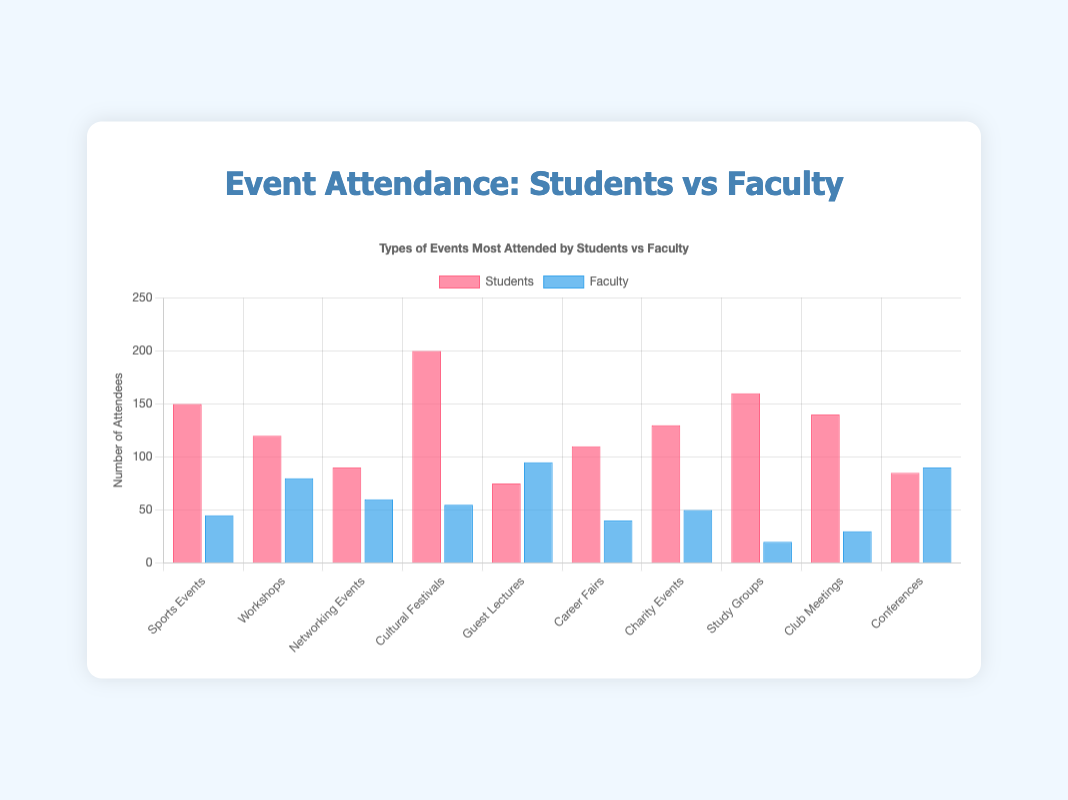Which event type had the highest attendance by students? The event type with the highest attendance by students is determined by inspecting the height of the red bars. Among all event types, the Cultural Festivals bar is the tallest in the students' dataset, indicating the highest attendance.
Answer: Cultural Festivals Which event type was the most popular among faculty members? The event type most popular among faculty members is revealed by looking at the tallest blue bar. The Guest Lectures bar is the tallest in the faculty dataset, indicating the highest attendance by faculty members.
Answer: Guest Lectures How many more students attended Cultural Festivals compared to faculty? To find this, look at the Cultural Festivals count for both students and faculty. Subtract the faculty count from the students' count: 200 (students) - 55 (faculty). The result is 145.
Answer: 145 Which event type had the closest attendance numbers between students and faculty? To determine this, compare the red and blue bars for each event type and identify the smallest difference. The closest attendance difference is seen for Conferences, where there are 85 students and 90 faculty members, giving a difference of only 5.
Answer: Conferences What is the average attendance by faculty members for all event types? To find the average attendance, sum the faculty members' attendance for all events and divide by the number of events: (45 + 80 + 60 + 55 + 95 + 40 + 50 + 20 + 30 + 90)/10 = 565/10 = 56.5
Answer: 56.5 Between Students and Faculty, who attended more Workshops, and by how much percentage? Compare the attendance figures for Workshops: 120 (students) and 80 (faculty). Calculate the percentage increase: ((120 - 80) / 80) * 100% = 50%.
Answer: Students, 50% Which events saw attendance by over 100 students? Events with attendance over 100 students are identified by bars exceeding the 100 mark. These are Sports Events (150), Cultural Festivals (200), Study Groups (160), Club Meetings (140), and Charity Events (130).
Answer: Sports Events, Cultural Festivals, Study Groups, Club Meetings, Charity Events What is the sum of total attendees (students and faculty combined) for Networking Events and Career Fairs? Add the attendees for students and faculty in both events: (90 + 60) + (110 + 40) = 150 + 150 = 300.
Answer: 300 In how many event types did faculty members attend more than students? Assess by comparing red and blue bars for each event type. Faculty attended more in Workshops (80 vs 120), Guest Lectures (95 vs 75), and Conferences (90 vs 85), totaling 3 events.
Answer: 3 Which event type has the second highest student attendance, and how many students attended? To identify the second highest, rank the red bars by height after Cultural Festivals (200). The next tallest bar is for Study Groups, with an attendance of 160 students.
Answer: Study Groups, 160 